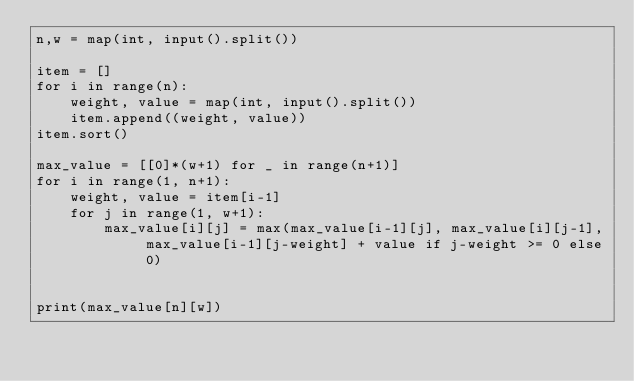<code> <loc_0><loc_0><loc_500><loc_500><_Python_>n,w = map(int, input().split())

item = []
for i in range(n):
    weight, value = map(int, input().split())
    item.append((weight, value))
item.sort()

max_value = [[0]*(w+1) for _ in range(n+1)]
for i in range(1, n+1):
    weight, value = item[i-1]
    for j in range(1, w+1):
        max_value[i][j] = max(max_value[i-1][j], max_value[i][j-1], max_value[i-1][j-weight] + value if j-weight >= 0 else 0)


print(max_value[n][w])</code> 